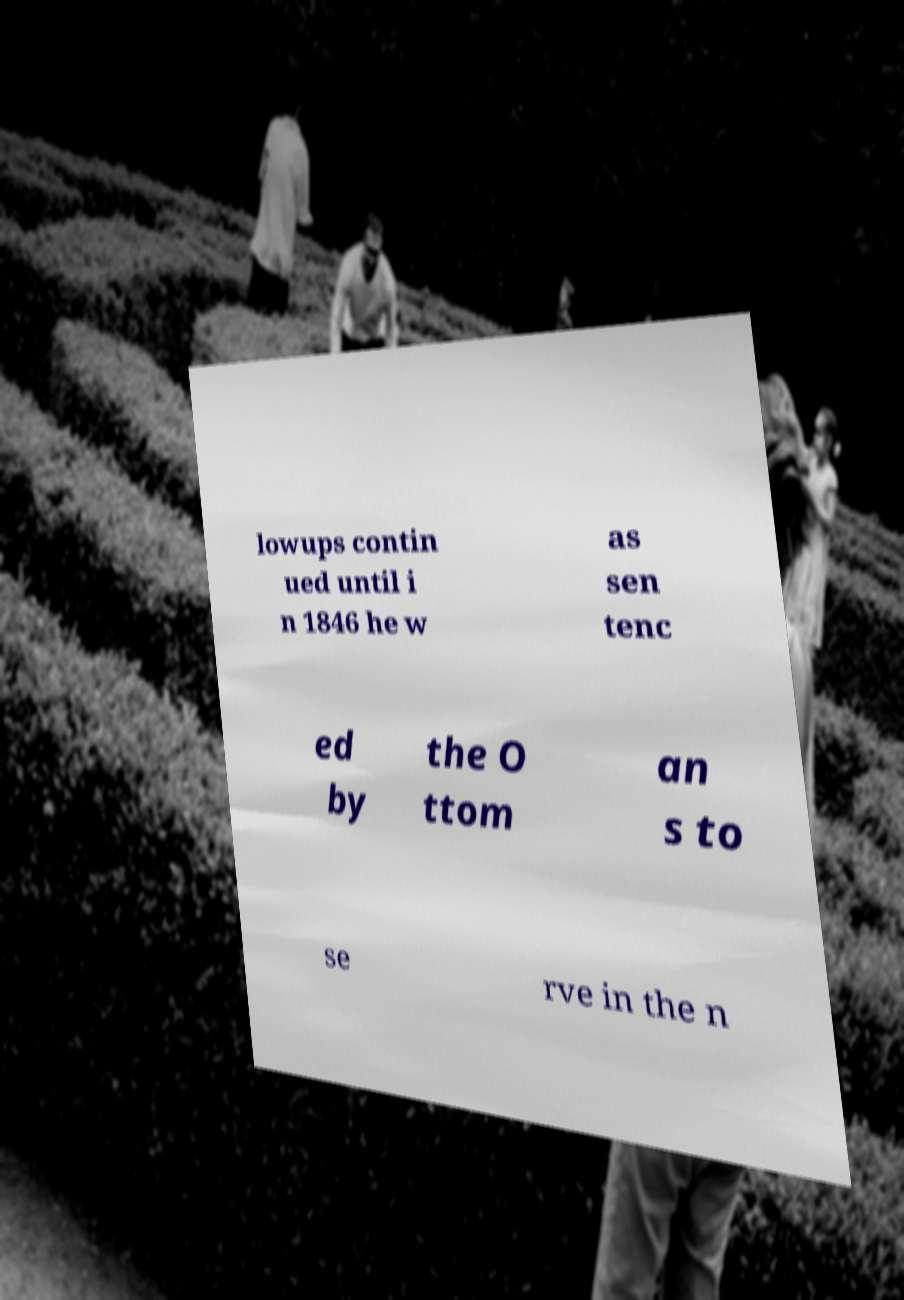There's text embedded in this image that I need extracted. Can you transcribe it verbatim? lowups contin ued until i n 1846 he w as sen tenc ed by the O ttom an s to se rve in the n 